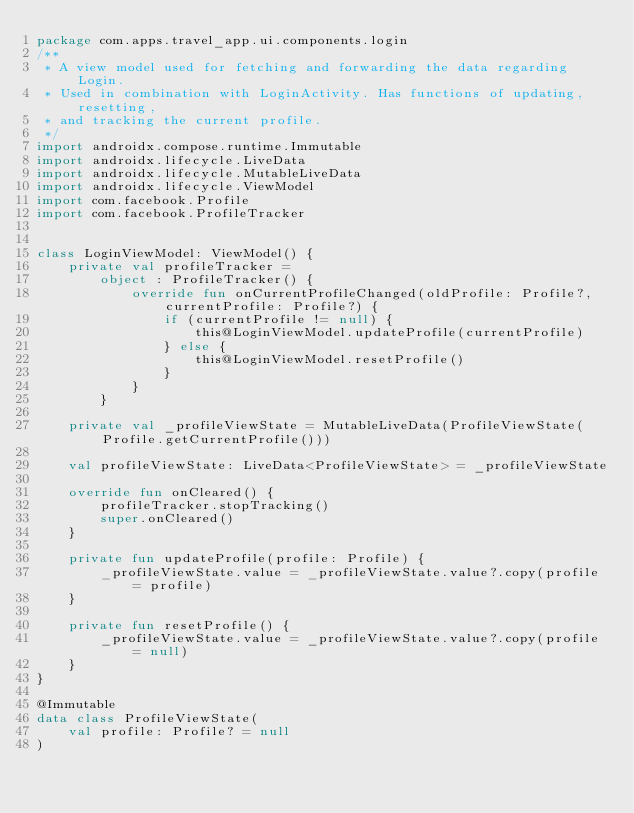Convert code to text. <code><loc_0><loc_0><loc_500><loc_500><_Kotlin_>package com.apps.travel_app.ui.components.login
/**
 * A view model used for fetching and forwarding the data regarding Login.
 * Used in combination with LoginActivity. Has functions of updating, resetting,
 * and tracking the current profile.
 */
import androidx.compose.runtime.Immutable
import androidx.lifecycle.LiveData
import androidx.lifecycle.MutableLiveData
import androidx.lifecycle.ViewModel
import com.facebook.Profile
import com.facebook.ProfileTracker


class LoginViewModel: ViewModel() {
    private val profileTracker =
        object : ProfileTracker() {
            override fun onCurrentProfileChanged(oldProfile: Profile?, currentProfile: Profile?) {
                if (currentProfile != null) {
                    this@LoginViewModel.updateProfile(currentProfile)
                } else {
                    this@LoginViewModel.resetProfile()
                }
            }
        }

    private val _profileViewState = MutableLiveData(ProfileViewState(Profile.getCurrentProfile()))

    val profileViewState: LiveData<ProfileViewState> = _profileViewState

    override fun onCleared() {
        profileTracker.stopTracking()
        super.onCleared()
    }

    private fun updateProfile(profile: Profile) {
        _profileViewState.value = _profileViewState.value?.copy(profile = profile)
    }

    private fun resetProfile() {
        _profileViewState.value = _profileViewState.value?.copy(profile = null)
    }
}

@Immutable
data class ProfileViewState(
    val profile: Profile? = null
)
</code> 